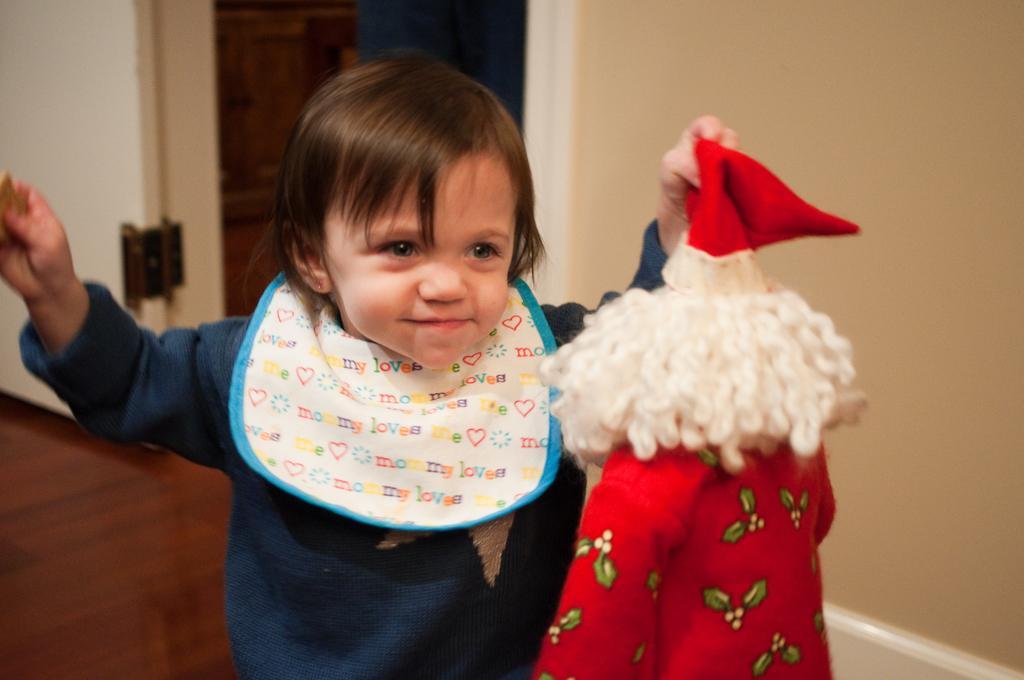Please provide a concise description of this image. In this image there is a boy holding the toy. In the background of the image there is a wall. On the left side of the image there is a door. At the bottom of the image there is a floor. 